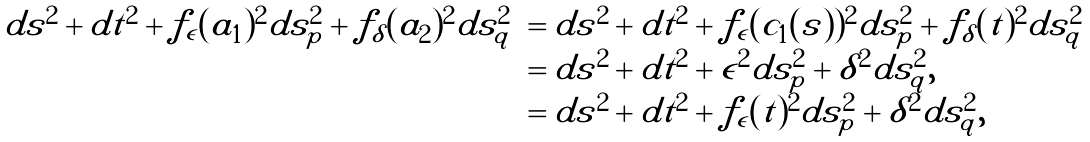Convert formula to latex. <formula><loc_0><loc_0><loc_500><loc_500>\begin{array} { c l c } d { s } ^ { 2 } + d t ^ { 2 } + f _ { \epsilon } ( a _ { 1 } ) ^ { 2 } d s _ { p } ^ { 2 } + f _ { \delta } ( a _ { 2 } ) ^ { 2 } d s _ { q } ^ { 2 } & = d { s } ^ { 2 } + d t ^ { 2 } + f _ { \epsilon } ( c _ { 1 } ( s ) ) ^ { 2 } d s _ { p } ^ { 2 } + f _ { \delta } ( t ) ^ { 2 } d s _ { q } ^ { 2 } \\ & = d { s } ^ { 2 } + d t ^ { 2 } + \epsilon ^ { 2 } d s _ { p } ^ { 2 } + { \delta } ^ { 2 } d s _ { q } ^ { 2 } , \\ & = d { s } ^ { 2 } + d t ^ { 2 } + f _ { \epsilon } ( t ) ^ { 2 } d s _ { p } ^ { 2 } + { \delta } ^ { 2 } d s _ { q } ^ { 2 } , \\ \end{array}</formula> 